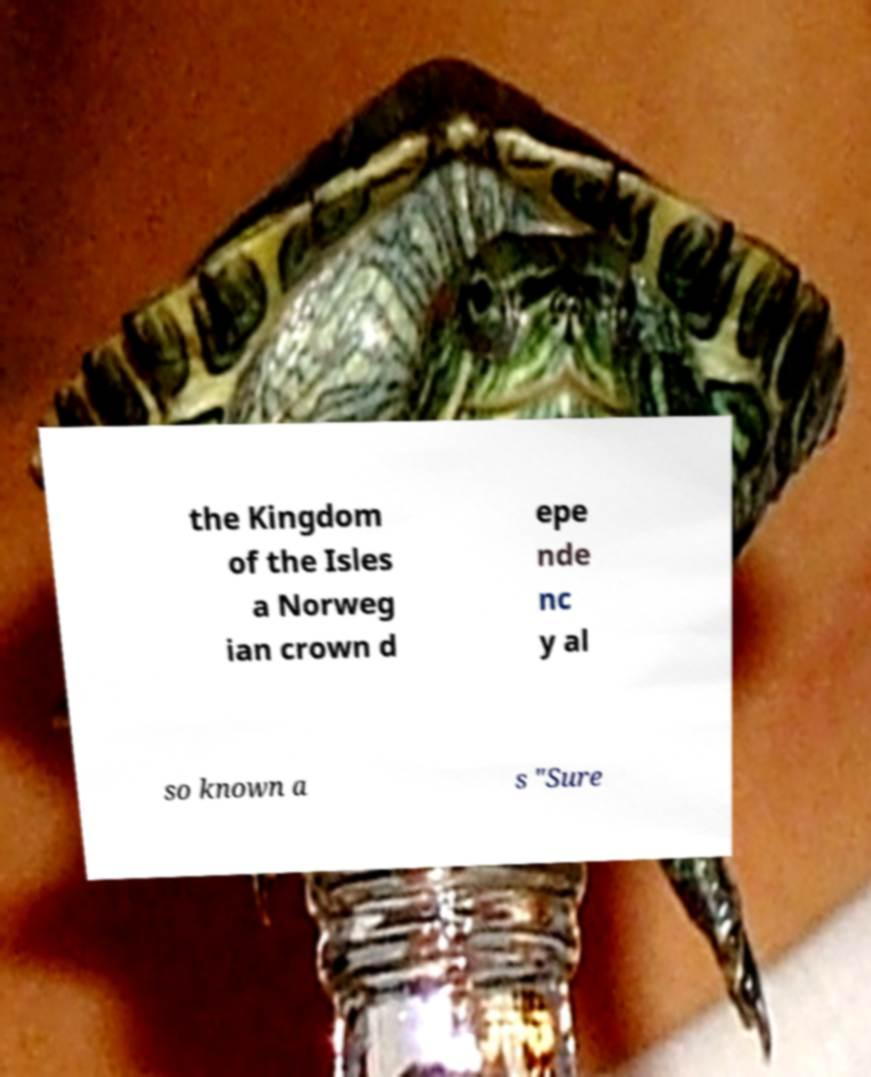I need the written content from this picture converted into text. Can you do that? the Kingdom of the Isles a Norweg ian crown d epe nde nc y al so known a s "Sure 